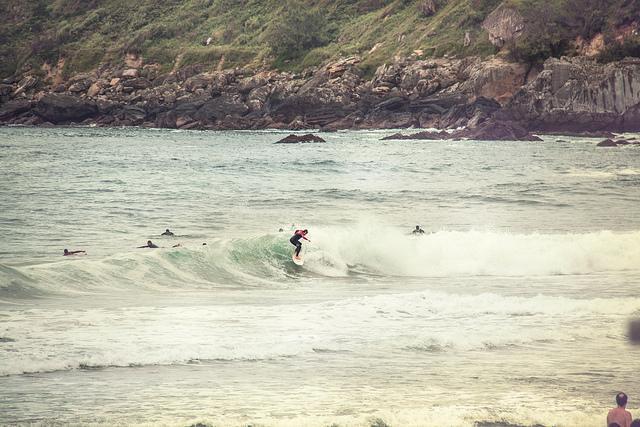What other activity can be carried out here besides surfing?
Choose the right answer from the provided options to respond to the question.
Options: Paddling, rafting, canoeing, swimming. Swimming. 